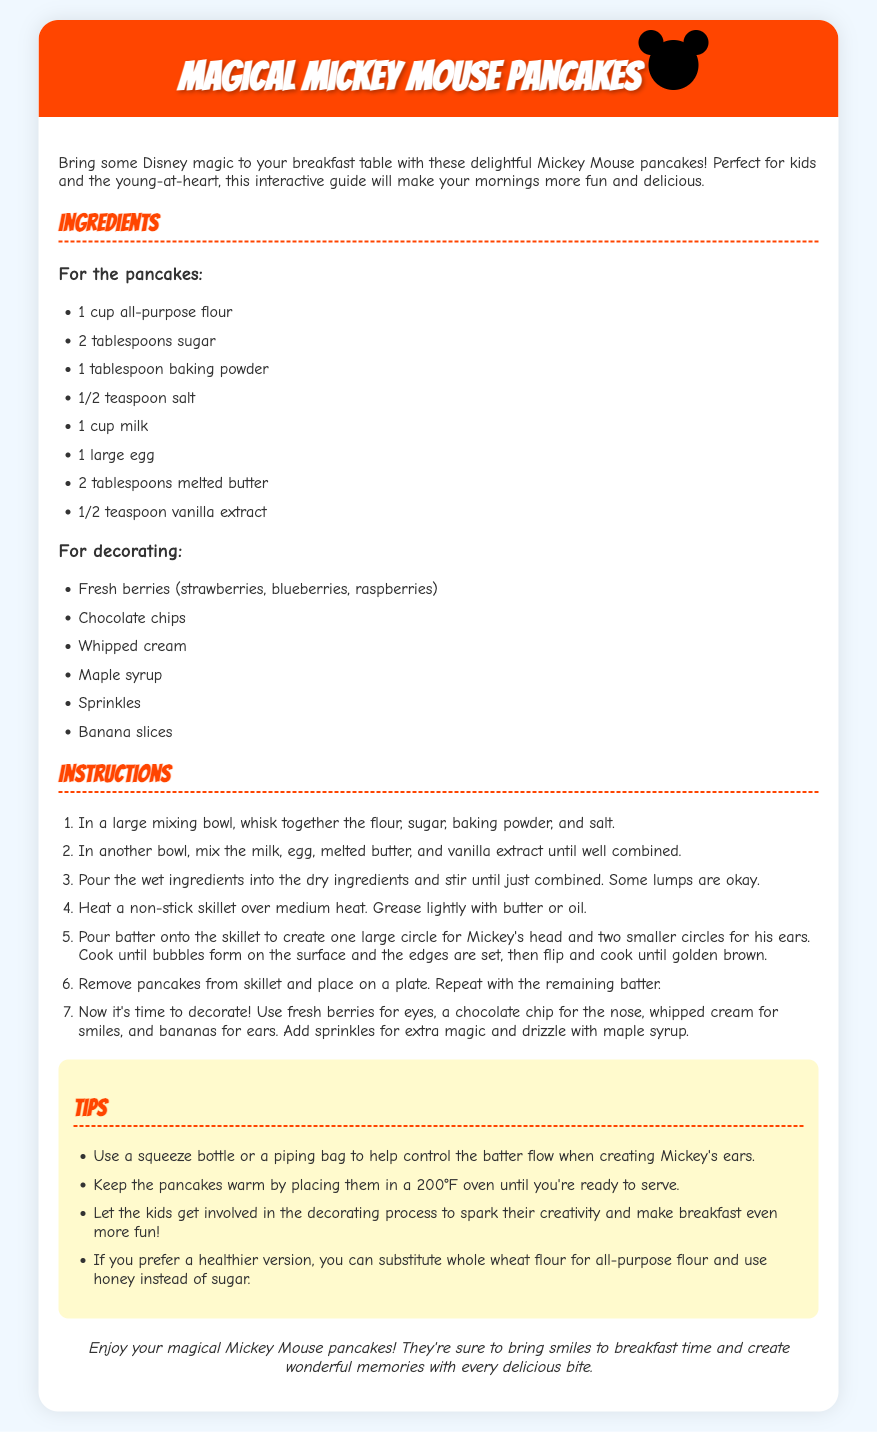What are the main ingredients for the pancakes? The main ingredients for the pancakes are listed in the "For the pancakes" section of the document.
Answer: 1 cup all-purpose flour, 2 tablespoons sugar, 1 tablespoon baking powder, 1/2 teaspoon salt, 1 cup milk, 1 large egg, 2 tablespoons melted butter, 1/2 teaspoon vanilla extract How many tablespoons of sugar are needed? The quantity of sugar required is specified under the pancakes ingredients.
Answer: 2 tablespoons What can be used for Mickey's ears? The document suggests using two smaller circles of batter to create Mickey's ears while cooking.
Answer: Two smaller circles What should you use for decorating? The document outlines items listed in the "For decorating" section as decoration options.
Answer: Fresh berries, chocolate chips, whipped cream, maple syrup, sprinkles, banana slices How many steps are in the instructions? The instructions section contains a step-by-step guide for making the pancakes, which can be counted.
Answer: 7 steps What is one tip for controlling batter flow? The tips section provides useful advice about tactics for making the pancakes.
Answer: Use a squeeze bottle or a piping bag What type of flour can be substituted for a healthier version? Reference to alternatives for healthier cooking can be found in the tips section.
Answer: Whole wheat flour What is the conclusion about the pancakes? The conclusion summarizes the overall experience of making and serving the pancakes.
Answer: They’re sure to bring smiles to breakfast time and create wonderful memories with every delicious bite 